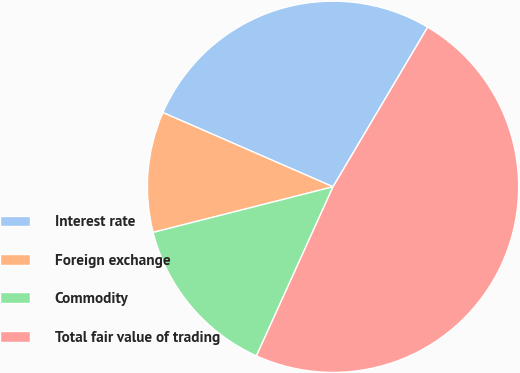Convert chart to OTSL. <chart><loc_0><loc_0><loc_500><loc_500><pie_chart><fcel>Interest rate<fcel>Foreign exchange<fcel>Commodity<fcel>Total fair value of trading<nl><fcel>26.97%<fcel>10.5%<fcel>14.28%<fcel>48.25%<nl></chart> 